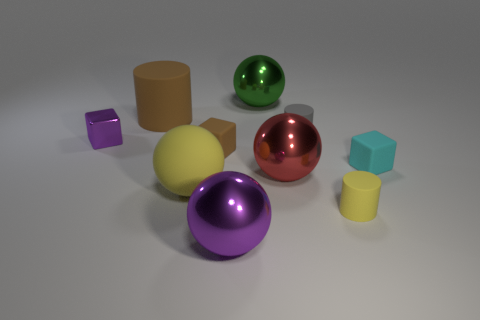There is a tiny object that is on the left side of the yellow rubber thing that is on the left side of the tiny gray thing; are there any yellow rubber objects that are left of it?
Offer a very short reply. No. There is a large red sphere; are there any rubber cylinders behind it?
Provide a succinct answer. Yes. There is a metal thing in front of the yellow matte cylinder; how many tiny yellow matte cylinders are to the left of it?
Make the answer very short. 0. Does the yellow rubber cylinder have the same size as the metallic object that is on the left side of the big purple ball?
Offer a terse response. Yes. Is there another cylinder that has the same color as the large matte cylinder?
Give a very brief answer. No. The yellow cylinder that is the same material as the big yellow sphere is what size?
Your response must be concise. Small. Are the green thing and the large brown object made of the same material?
Offer a terse response. No. What color is the tiny cylinder on the left side of the yellow thing to the right of the tiny cylinder that is behind the small purple object?
Your response must be concise. Gray. What is the shape of the red metallic object?
Give a very brief answer. Sphere. Is the color of the small shiny cube the same as the sphere that is on the left side of the large purple thing?
Make the answer very short. No. 